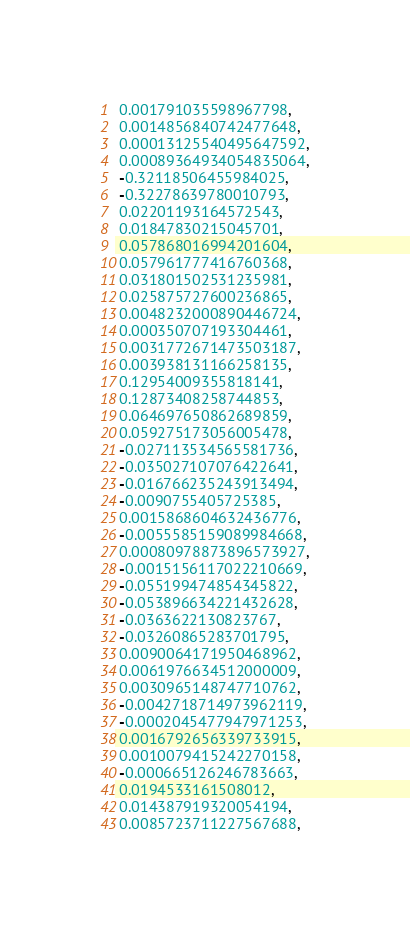Convert code to text. <code><loc_0><loc_0><loc_500><loc_500><_Python_> 0.001791035598967798,
 0.0014856840742477648,
 0.00013125540495647592,
 0.00089364934054835064,
 -0.32118506455984025,
 -0.32278639780010793,
 0.02201193164572543,
 0.01847830215045701,
 0.057868016994201604,
 0.057961777416760368,
 0.031801502531235981,
 0.025875727600236865,
 0.0048232000890446724,
 0.000350707193304461,
 0.0031772671473503187,
 0.003938131166258135,
 0.12954009355818141,
 0.12873408258744853,
 0.064697650862689859,
 0.059275173056005478,
 -0.027113534565581736,
 -0.035027107076422641,
 -0.016766235243913494,
 -0.0090755405725385,
 0.0015868604632436776,
 -0.0055585159089984668,
 0.00080978873896573927,
 -0.0015156117022210669,
 -0.055199474854345822,
 -0.053896634221432628,
 -0.0363622130823767,
 -0.03260865283701795,
 0.0090064171950468962,
 0.0061976634512000009,
 0.0030965148747710762,
 -0.0042718714973962119,
 -0.0002045477947971253,
 0.0016792656339733915,
 0.0010079415242270158,
 -0.000665126246783663,
 0.0194533161508012,
 0.014387919320054194,
 0.0085723711227567688,</code> 